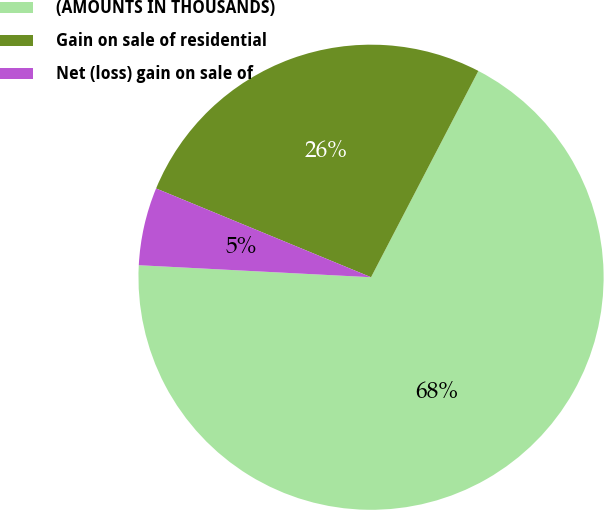<chart> <loc_0><loc_0><loc_500><loc_500><pie_chart><fcel>(AMOUNTS IN THOUSANDS)<fcel>Gain on sale of residential<fcel>Net (loss) gain on sale of<nl><fcel>68.19%<fcel>26.4%<fcel>5.41%<nl></chart> 